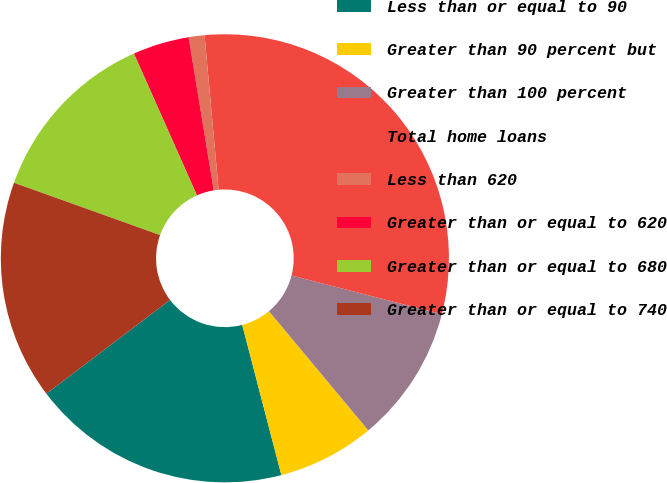Convert chart. <chart><loc_0><loc_0><loc_500><loc_500><pie_chart><fcel>Less than or equal to 90<fcel>Greater than 90 percent but<fcel>Greater than 100 percent<fcel>Total home loans<fcel>Less than 620<fcel>Greater than or equal to 620<fcel>Greater than or equal to 680<fcel>Greater than or equal to 740<nl><fcel>18.73%<fcel>7.0%<fcel>9.93%<fcel>30.46%<fcel>1.14%<fcel>4.07%<fcel>12.87%<fcel>15.8%<nl></chart> 